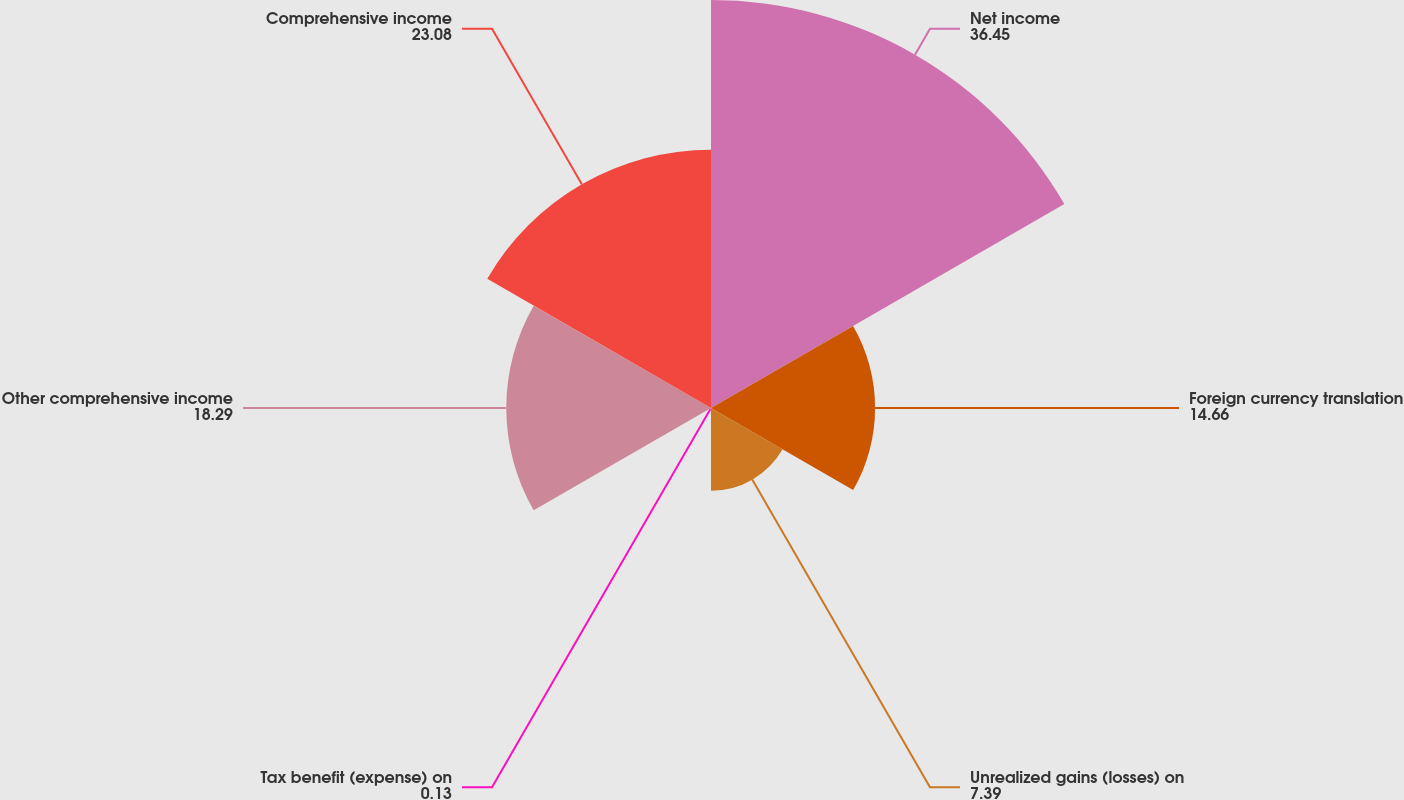Convert chart to OTSL. <chart><loc_0><loc_0><loc_500><loc_500><pie_chart><fcel>Net income<fcel>Foreign currency translation<fcel>Unrealized gains (losses) on<fcel>Tax benefit (expense) on<fcel>Other comprehensive income<fcel>Comprehensive income<nl><fcel>36.45%<fcel>14.66%<fcel>7.39%<fcel>0.13%<fcel>18.29%<fcel>23.08%<nl></chart> 